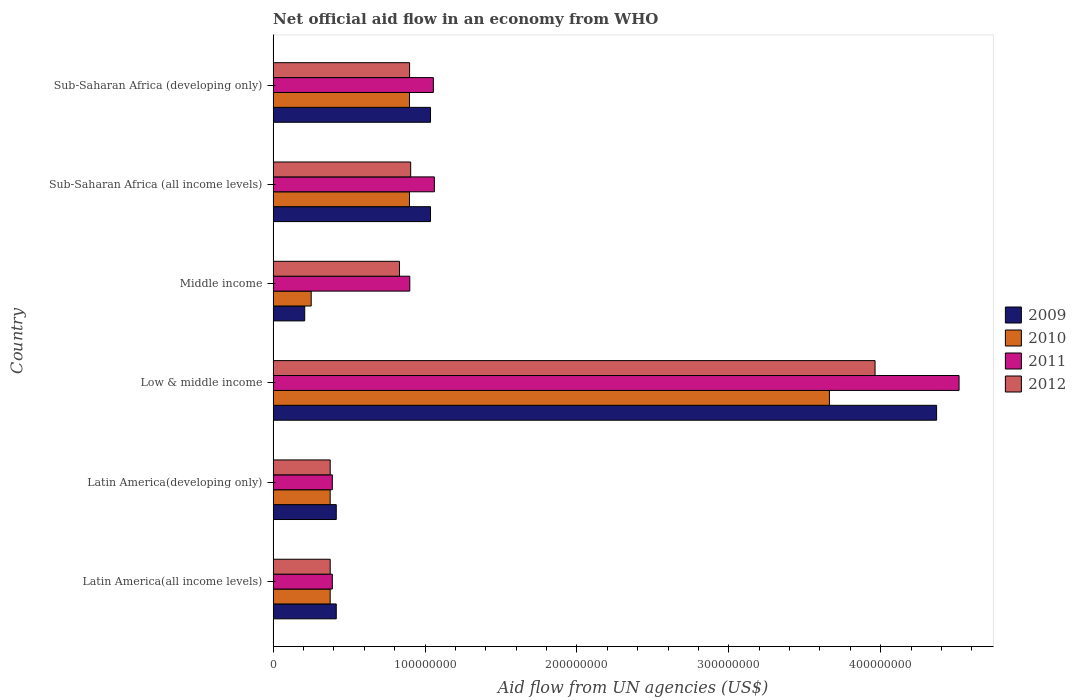How many groups of bars are there?
Offer a terse response. 6. Are the number of bars per tick equal to the number of legend labels?
Ensure brevity in your answer.  Yes. How many bars are there on the 1st tick from the top?
Your response must be concise. 4. How many bars are there on the 4th tick from the bottom?
Give a very brief answer. 4. What is the label of the 5th group of bars from the top?
Offer a very short reply. Latin America(developing only). In how many cases, is the number of bars for a given country not equal to the number of legend labels?
Make the answer very short. 0. What is the net official aid flow in 2009 in Sub-Saharan Africa (developing only)?
Provide a succinct answer. 1.04e+08. Across all countries, what is the maximum net official aid flow in 2010?
Provide a succinct answer. 3.66e+08. Across all countries, what is the minimum net official aid flow in 2010?
Ensure brevity in your answer.  2.51e+07. In which country was the net official aid flow in 2010 minimum?
Ensure brevity in your answer.  Middle income. What is the total net official aid flow in 2011 in the graph?
Offer a very short reply. 8.31e+08. What is the difference between the net official aid flow in 2009 in Low & middle income and that in Middle income?
Ensure brevity in your answer.  4.16e+08. What is the difference between the net official aid flow in 2010 in Sub-Saharan Africa (all income levels) and the net official aid flow in 2011 in Low & middle income?
Give a very brief answer. -3.62e+08. What is the average net official aid flow in 2012 per country?
Your response must be concise. 1.23e+08. What is the difference between the net official aid flow in 2011 and net official aid flow in 2012 in Low & middle income?
Provide a succinct answer. 5.53e+07. What is the ratio of the net official aid flow in 2010 in Latin America(developing only) to that in Low & middle income?
Ensure brevity in your answer.  0.1. Is the net official aid flow in 2010 in Middle income less than that in Sub-Saharan Africa (all income levels)?
Ensure brevity in your answer.  Yes. Is the difference between the net official aid flow in 2011 in Latin America(all income levels) and Latin America(developing only) greater than the difference between the net official aid flow in 2012 in Latin America(all income levels) and Latin America(developing only)?
Your answer should be very brief. No. What is the difference between the highest and the second highest net official aid flow in 2011?
Your response must be concise. 3.45e+08. What is the difference between the highest and the lowest net official aid flow in 2010?
Provide a succinct answer. 3.41e+08. In how many countries, is the net official aid flow in 2009 greater than the average net official aid flow in 2009 taken over all countries?
Your answer should be very brief. 1. Is it the case that in every country, the sum of the net official aid flow in 2012 and net official aid flow in 2009 is greater than the sum of net official aid flow in 2011 and net official aid flow in 2010?
Provide a short and direct response. Yes. Is it the case that in every country, the sum of the net official aid flow in 2009 and net official aid flow in 2012 is greater than the net official aid flow in 2010?
Give a very brief answer. Yes. How many bars are there?
Keep it short and to the point. 24. How many countries are there in the graph?
Ensure brevity in your answer.  6. Does the graph contain grids?
Offer a terse response. No. Where does the legend appear in the graph?
Offer a terse response. Center right. How are the legend labels stacked?
Your answer should be compact. Vertical. What is the title of the graph?
Provide a succinct answer. Net official aid flow in an economy from WHO. What is the label or title of the X-axis?
Your answer should be compact. Aid flow from UN agencies (US$). What is the Aid flow from UN agencies (US$) of 2009 in Latin America(all income levels)?
Give a very brief answer. 4.16e+07. What is the Aid flow from UN agencies (US$) of 2010 in Latin America(all income levels)?
Keep it short and to the point. 3.76e+07. What is the Aid flow from UN agencies (US$) of 2011 in Latin America(all income levels)?
Provide a succinct answer. 3.90e+07. What is the Aid flow from UN agencies (US$) in 2012 in Latin America(all income levels)?
Offer a very short reply. 3.76e+07. What is the Aid flow from UN agencies (US$) of 2009 in Latin America(developing only)?
Ensure brevity in your answer.  4.16e+07. What is the Aid flow from UN agencies (US$) in 2010 in Latin America(developing only)?
Offer a terse response. 3.76e+07. What is the Aid flow from UN agencies (US$) in 2011 in Latin America(developing only)?
Keep it short and to the point. 3.90e+07. What is the Aid flow from UN agencies (US$) in 2012 in Latin America(developing only)?
Provide a short and direct response. 3.76e+07. What is the Aid flow from UN agencies (US$) in 2009 in Low & middle income?
Your response must be concise. 4.37e+08. What is the Aid flow from UN agencies (US$) in 2010 in Low & middle income?
Provide a succinct answer. 3.66e+08. What is the Aid flow from UN agencies (US$) of 2011 in Low & middle income?
Your answer should be very brief. 4.52e+08. What is the Aid flow from UN agencies (US$) in 2012 in Low & middle income?
Keep it short and to the point. 3.96e+08. What is the Aid flow from UN agencies (US$) of 2009 in Middle income?
Offer a very short reply. 2.08e+07. What is the Aid flow from UN agencies (US$) of 2010 in Middle income?
Your response must be concise. 2.51e+07. What is the Aid flow from UN agencies (US$) of 2011 in Middle income?
Give a very brief answer. 9.00e+07. What is the Aid flow from UN agencies (US$) in 2012 in Middle income?
Provide a succinct answer. 8.32e+07. What is the Aid flow from UN agencies (US$) of 2009 in Sub-Saharan Africa (all income levels)?
Offer a terse response. 1.04e+08. What is the Aid flow from UN agencies (US$) of 2010 in Sub-Saharan Africa (all income levels)?
Make the answer very short. 8.98e+07. What is the Aid flow from UN agencies (US$) of 2011 in Sub-Saharan Africa (all income levels)?
Provide a succinct answer. 1.06e+08. What is the Aid flow from UN agencies (US$) of 2012 in Sub-Saharan Africa (all income levels)?
Keep it short and to the point. 9.06e+07. What is the Aid flow from UN agencies (US$) of 2009 in Sub-Saharan Africa (developing only)?
Ensure brevity in your answer.  1.04e+08. What is the Aid flow from UN agencies (US$) in 2010 in Sub-Saharan Africa (developing only)?
Your response must be concise. 8.98e+07. What is the Aid flow from UN agencies (US$) of 2011 in Sub-Saharan Africa (developing only)?
Offer a terse response. 1.05e+08. What is the Aid flow from UN agencies (US$) of 2012 in Sub-Saharan Africa (developing only)?
Offer a terse response. 8.98e+07. Across all countries, what is the maximum Aid flow from UN agencies (US$) of 2009?
Your answer should be very brief. 4.37e+08. Across all countries, what is the maximum Aid flow from UN agencies (US$) of 2010?
Make the answer very short. 3.66e+08. Across all countries, what is the maximum Aid flow from UN agencies (US$) in 2011?
Your answer should be very brief. 4.52e+08. Across all countries, what is the maximum Aid flow from UN agencies (US$) of 2012?
Offer a terse response. 3.96e+08. Across all countries, what is the minimum Aid flow from UN agencies (US$) of 2009?
Your answer should be very brief. 2.08e+07. Across all countries, what is the minimum Aid flow from UN agencies (US$) of 2010?
Provide a short and direct response. 2.51e+07. Across all countries, what is the minimum Aid flow from UN agencies (US$) of 2011?
Provide a succinct answer. 3.90e+07. Across all countries, what is the minimum Aid flow from UN agencies (US$) of 2012?
Your answer should be very brief. 3.76e+07. What is the total Aid flow from UN agencies (US$) of 2009 in the graph?
Your response must be concise. 7.48e+08. What is the total Aid flow from UN agencies (US$) in 2010 in the graph?
Give a very brief answer. 6.46e+08. What is the total Aid flow from UN agencies (US$) of 2011 in the graph?
Ensure brevity in your answer.  8.31e+08. What is the total Aid flow from UN agencies (US$) of 2012 in the graph?
Your response must be concise. 7.35e+08. What is the difference between the Aid flow from UN agencies (US$) in 2009 in Latin America(all income levels) and that in Latin America(developing only)?
Provide a short and direct response. 0. What is the difference between the Aid flow from UN agencies (US$) in 2010 in Latin America(all income levels) and that in Latin America(developing only)?
Your response must be concise. 0. What is the difference between the Aid flow from UN agencies (US$) of 2012 in Latin America(all income levels) and that in Latin America(developing only)?
Make the answer very short. 0. What is the difference between the Aid flow from UN agencies (US$) in 2009 in Latin America(all income levels) and that in Low & middle income?
Your answer should be very brief. -3.95e+08. What is the difference between the Aid flow from UN agencies (US$) in 2010 in Latin America(all income levels) and that in Low & middle income?
Your response must be concise. -3.29e+08. What is the difference between the Aid flow from UN agencies (US$) of 2011 in Latin America(all income levels) and that in Low & middle income?
Ensure brevity in your answer.  -4.13e+08. What is the difference between the Aid flow from UN agencies (US$) in 2012 in Latin America(all income levels) and that in Low & middle income?
Make the answer very short. -3.59e+08. What is the difference between the Aid flow from UN agencies (US$) of 2009 in Latin America(all income levels) and that in Middle income?
Offer a terse response. 2.08e+07. What is the difference between the Aid flow from UN agencies (US$) of 2010 in Latin America(all income levels) and that in Middle income?
Offer a terse response. 1.25e+07. What is the difference between the Aid flow from UN agencies (US$) of 2011 in Latin America(all income levels) and that in Middle income?
Provide a short and direct response. -5.10e+07. What is the difference between the Aid flow from UN agencies (US$) of 2012 in Latin America(all income levels) and that in Middle income?
Ensure brevity in your answer.  -4.56e+07. What is the difference between the Aid flow from UN agencies (US$) of 2009 in Latin America(all income levels) and that in Sub-Saharan Africa (all income levels)?
Keep it short and to the point. -6.20e+07. What is the difference between the Aid flow from UN agencies (US$) of 2010 in Latin America(all income levels) and that in Sub-Saharan Africa (all income levels)?
Ensure brevity in your answer.  -5.22e+07. What is the difference between the Aid flow from UN agencies (US$) in 2011 in Latin America(all income levels) and that in Sub-Saharan Africa (all income levels)?
Keep it short and to the point. -6.72e+07. What is the difference between the Aid flow from UN agencies (US$) of 2012 in Latin America(all income levels) and that in Sub-Saharan Africa (all income levels)?
Make the answer very short. -5.30e+07. What is the difference between the Aid flow from UN agencies (US$) of 2009 in Latin America(all income levels) and that in Sub-Saharan Africa (developing only)?
Offer a terse response. -6.20e+07. What is the difference between the Aid flow from UN agencies (US$) in 2010 in Latin America(all income levels) and that in Sub-Saharan Africa (developing only)?
Your answer should be compact. -5.22e+07. What is the difference between the Aid flow from UN agencies (US$) of 2011 in Latin America(all income levels) and that in Sub-Saharan Africa (developing only)?
Make the answer very short. -6.65e+07. What is the difference between the Aid flow from UN agencies (US$) in 2012 in Latin America(all income levels) and that in Sub-Saharan Africa (developing only)?
Offer a terse response. -5.23e+07. What is the difference between the Aid flow from UN agencies (US$) of 2009 in Latin America(developing only) and that in Low & middle income?
Provide a succinct answer. -3.95e+08. What is the difference between the Aid flow from UN agencies (US$) in 2010 in Latin America(developing only) and that in Low & middle income?
Your response must be concise. -3.29e+08. What is the difference between the Aid flow from UN agencies (US$) in 2011 in Latin America(developing only) and that in Low & middle income?
Provide a succinct answer. -4.13e+08. What is the difference between the Aid flow from UN agencies (US$) of 2012 in Latin America(developing only) and that in Low & middle income?
Make the answer very short. -3.59e+08. What is the difference between the Aid flow from UN agencies (US$) in 2009 in Latin America(developing only) and that in Middle income?
Your answer should be compact. 2.08e+07. What is the difference between the Aid flow from UN agencies (US$) of 2010 in Latin America(developing only) and that in Middle income?
Provide a short and direct response. 1.25e+07. What is the difference between the Aid flow from UN agencies (US$) in 2011 in Latin America(developing only) and that in Middle income?
Make the answer very short. -5.10e+07. What is the difference between the Aid flow from UN agencies (US$) in 2012 in Latin America(developing only) and that in Middle income?
Provide a succinct answer. -4.56e+07. What is the difference between the Aid flow from UN agencies (US$) of 2009 in Latin America(developing only) and that in Sub-Saharan Africa (all income levels)?
Offer a very short reply. -6.20e+07. What is the difference between the Aid flow from UN agencies (US$) of 2010 in Latin America(developing only) and that in Sub-Saharan Africa (all income levels)?
Your answer should be very brief. -5.22e+07. What is the difference between the Aid flow from UN agencies (US$) of 2011 in Latin America(developing only) and that in Sub-Saharan Africa (all income levels)?
Your response must be concise. -6.72e+07. What is the difference between the Aid flow from UN agencies (US$) of 2012 in Latin America(developing only) and that in Sub-Saharan Africa (all income levels)?
Keep it short and to the point. -5.30e+07. What is the difference between the Aid flow from UN agencies (US$) of 2009 in Latin America(developing only) and that in Sub-Saharan Africa (developing only)?
Your response must be concise. -6.20e+07. What is the difference between the Aid flow from UN agencies (US$) in 2010 in Latin America(developing only) and that in Sub-Saharan Africa (developing only)?
Your answer should be very brief. -5.22e+07. What is the difference between the Aid flow from UN agencies (US$) of 2011 in Latin America(developing only) and that in Sub-Saharan Africa (developing only)?
Your response must be concise. -6.65e+07. What is the difference between the Aid flow from UN agencies (US$) of 2012 in Latin America(developing only) and that in Sub-Saharan Africa (developing only)?
Provide a short and direct response. -5.23e+07. What is the difference between the Aid flow from UN agencies (US$) of 2009 in Low & middle income and that in Middle income?
Your response must be concise. 4.16e+08. What is the difference between the Aid flow from UN agencies (US$) of 2010 in Low & middle income and that in Middle income?
Your response must be concise. 3.41e+08. What is the difference between the Aid flow from UN agencies (US$) in 2011 in Low & middle income and that in Middle income?
Offer a very short reply. 3.62e+08. What is the difference between the Aid flow from UN agencies (US$) of 2012 in Low & middle income and that in Middle income?
Keep it short and to the point. 3.13e+08. What is the difference between the Aid flow from UN agencies (US$) of 2009 in Low & middle income and that in Sub-Saharan Africa (all income levels)?
Ensure brevity in your answer.  3.33e+08. What is the difference between the Aid flow from UN agencies (US$) of 2010 in Low & middle income and that in Sub-Saharan Africa (all income levels)?
Your answer should be compact. 2.76e+08. What is the difference between the Aid flow from UN agencies (US$) of 2011 in Low & middle income and that in Sub-Saharan Africa (all income levels)?
Your response must be concise. 3.45e+08. What is the difference between the Aid flow from UN agencies (US$) in 2012 in Low & middle income and that in Sub-Saharan Africa (all income levels)?
Your answer should be compact. 3.06e+08. What is the difference between the Aid flow from UN agencies (US$) of 2009 in Low & middle income and that in Sub-Saharan Africa (developing only)?
Offer a terse response. 3.33e+08. What is the difference between the Aid flow from UN agencies (US$) of 2010 in Low & middle income and that in Sub-Saharan Africa (developing only)?
Your answer should be compact. 2.76e+08. What is the difference between the Aid flow from UN agencies (US$) of 2011 in Low & middle income and that in Sub-Saharan Africa (developing only)?
Keep it short and to the point. 3.46e+08. What is the difference between the Aid flow from UN agencies (US$) of 2012 in Low & middle income and that in Sub-Saharan Africa (developing only)?
Make the answer very short. 3.06e+08. What is the difference between the Aid flow from UN agencies (US$) in 2009 in Middle income and that in Sub-Saharan Africa (all income levels)?
Give a very brief answer. -8.28e+07. What is the difference between the Aid flow from UN agencies (US$) in 2010 in Middle income and that in Sub-Saharan Africa (all income levels)?
Provide a short and direct response. -6.47e+07. What is the difference between the Aid flow from UN agencies (US$) of 2011 in Middle income and that in Sub-Saharan Africa (all income levels)?
Your response must be concise. -1.62e+07. What is the difference between the Aid flow from UN agencies (US$) in 2012 in Middle income and that in Sub-Saharan Africa (all income levels)?
Provide a succinct answer. -7.39e+06. What is the difference between the Aid flow from UN agencies (US$) of 2009 in Middle income and that in Sub-Saharan Africa (developing only)?
Your answer should be compact. -8.28e+07. What is the difference between the Aid flow from UN agencies (US$) of 2010 in Middle income and that in Sub-Saharan Africa (developing only)?
Your answer should be very brief. -6.47e+07. What is the difference between the Aid flow from UN agencies (US$) of 2011 in Middle income and that in Sub-Saharan Africa (developing only)?
Your response must be concise. -1.55e+07. What is the difference between the Aid flow from UN agencies (US$) in 2012 in Middle income and that in Sub-Saharan Africa (developing only)?
Make the answer very short. -6.67e+06. What is the difference between the Aid flow from UN agencies (US$) in 2009 in Sub-Saharan Africa (all income levels) and that in Sub-Saharan Africa (developing only)?
Provide a short and direct response. 0. What is the difference between the Aid flow from UN agencies (US$) of 2011 in Sub-Saharan Africa (all income levels) and that in Sub-Saharan Africa (developing only)?
Make the answer very short. 6.70e+05. What is the difference between the Aid flow from UN agencies (US$) in 2012 in Sub-Saharan Africa (all income levels) and that in Sub-Saharan Africa (developing only)?
Keep it short and to the point. 7.20e+05. What is the difference between the Aid flow from UN agencies (US$) in 2009 in Latin America(all income levels) and the Aid flow from UN agencies (US$) in 2010 in Latin America(developing only)?
Make the answer very short. 4.01e+06. What is the difference between the Aid flow from UN agencies (US$) in 2009 in Latin America(all income levels) and the Aid flow from UN agencies (US$) in 2011 in Latin America(developing only)?
Offer a very short reply. 2.59e+06. What is the difference between the Aid flow from UN agencies (US$) of 2009 in Latin America(all income levels) and the Aid flow from UN agencies (US$) of 2012 in Latin America(developing only)?
Make the answer very short. 3.99e+06. What is the difference between the Aid flow from UN agencies (US$) of 2010 in Latin America(all income levels) and the Aid flow from UN agencies (US$) of 2011 in Latin America(developing only)?
Give a very brief answer. -1.42e+06. What is the difference between the Aid flow from UN agencies (US$) of 2011 in Latin America(all income levels) and the Aid flow from UN agencies (US$) of 2012 in Latin America(developing only)?
Ensure brevity in your answer.  1.40e+06. What is the difference between the Aid flow from UN agencies (US$) of 2009 in Latin America(all income levels) and the Aid flow from UN agencies (US$) of 2010 in Low & middle income?
Offer a terse response. -3.25e+08. What is the difference between the Aid flow from UN agencies (US$) in 2009 in Latin America(all income levels) and the Aid flow from UN agencies (US$) in 2011 in Low & middle income?
Ensure brevity in your answer.  -4.10e+08. What is the difference between the Aid flow from UN agencies (US$) of 2009 in Latin America(all income levels) and the Aid flow from UN agencies (US$) of 2012 in Low & middle income?
Ensure brevity in your answer.  -3.55e+08. What is the difference between the Aid flow from UN agencies (US$) of 2010 in Latin America(all income levels) and the Aid flow from UN agencies (US$) of 2011 in Low & middle income?
Your answer should be compact. -4.14e+08. What is the difference between the Aid flow from UN agencies (US$) in 2010 in Latin America(all income levels) and the Aid flow from UN agencies (US$) in 2012 in Low & middle income?
Give a very brief answer. -3.59e+08. What is the difference between the Aid flow from UN agencies (US$) in 2011 in Latin America(all income levels) and the Aid flow from UN agencies (US$) in 2012 in Low & middle income?
Your answer should be compact. -3.57e+08. What is the difference between the Aid flow from UN agencies (US$) of 2009 in Latin America(all income levels) and the Aid flow from UN agencies (US$) of 2010 in Middle income?
Your answer should be very brief. 1.65e+07. What is the difference between the Aid flow from UN agencies (US$) of 2009 in Latin America(all income levels) and the Aid flow from UN agencies (US$) of 2011 in Middle income?
Give a very brief answer. -4.84e+07. What is the difference between the Aid flow from UN agencies (US$) of 2009 in Latin America(all income levels) and the Aid flow from UN agencies (US$) of 2012 in Middle income?
Give a very brief answer. -4.16e+07. What is the difference between the Aid flow from UN agencies (US$) in 2010 in Latin America(all income levels) and the Aid flow from UN agencies (US$) in 2011 in Middle income?
Keep it short and to the point. -5.24e+07. What is the difference between the Aid flow from UN agencies (US$) in 2010 in Latin America(all income levels) and the Aid flow from UN agencies (US$) in 2012 in Middle income?
Your answer should be compact. -4.56e+07. What is the difference between the Aid flow from UN agencies (US$) of 2011 in Latin America(all income levels) and the Aid flow from UN agencies (US$) of 2012 in Middle income?
Provide a succinct answer. -4.42e+07. What is the difference between the Aid flow from UN agencies (US$) of 2009 in Latin America(all income levels) and the Aid flow from UN agencies (US$) of 2010 in Sub-Saharan Africa (all income levels)?
Ensure brevity in your answer.  -4.82e+07. What is the difference between the Aid flow from UN agencies (US$) of 2009 in Latin America(all income levels) and the Aid flow from UN agencies (US$) of 2011 in Sub-Saharan Africa (all income levels)?
Provide a short and direct response. -6.46e+07. What is the difference between the Aid flow from UN agencies (US$) in 2009 in Latin America(all income levels) and the Aid flow from UN agencies (US$) in 2012 in Sub-Saharan Africa (all income levels)?
Your response must be concise. -4.90e+07. What is the difference between the Aid flow from UN agencies (US$) of 2010 in Latin America(all income levels) and the Aid flow from UN agencies (US$) of 2011 in Sub-Saharan Africa (all income levels)?
Give a very brief answer. -6.86e+07. What is the difference between the Aid flow from UN agencies (US$) in 2010 in Latin America(all income levels) and the Aid flow from UN agencies (US$) in 2012 in Sub-Saharan Africa (all income levels)?
Provide a succinct answer. -5.30e+07. What is the difference between the Aid flow from UN agencies (US$) of 2011 in Latin America(all income levels) and the Aid flow from UN agencies (US$) of 2012 in Sub-Saharan Africa (all income levels)?
Your response must be concise. -5.16e+07. What is the difference between the Aid flow from UN agencies (US$) in 2009 in Latin America(all income levels) and the Aid flow from UN agencies (US$) in 2010 in Sub-Saharan Africa (developing only)?
Give a very brief answer. -4.82e+07. What is the difference between the Aid flow from UN agencies (US$) in 2009 in Latin America(all income levels) and the Aid flow from UN agencies (US$) in 2011 in Sub-Saharan Africa (developing only)?
Ensure brevity in your answer.  -6.39e+07. What is the difference between the Aid flow from UN agencies (US$) in 2009 in Latin America(all income levels) and the Aid flow from UN agencies (US$) in 2012 in Sub-Saharan Africa (developing only)?
Ensure brevity in your answer.  -4.83e+07. What is the difference between the Aid flow from UN agencies (US$) in 2010 in Latin America(all income levels) and the Aid flow from UN agencies (US$) in 2011 in Sub-Saharan Africa (developing only)?
Your answer should be compact. -6.79e+07. What is the difference between the Aid flow from UN agencies (US$) of 2010 in Latin America(all income levels) and the Aid flow from UN agencies (US$) of 2012 in Sub-Saharan Africa (developing only)?
Provide a succinct answer. -5.23e+07. What is the difference between the Aid flow from UN agencies (US$) in 2011 in Latin America(all income levels) and the Aid flow from UN agencies (US$) in 2012 in Sub-Saharan Africa (developing only)?
Make the answer very short. -5.09e+07. What is the difference between the Aid flow from UN agencies (US$) of 2009 in Latin America(developing only) and the Aid flow from UN agencies (US$) of 2010 in Low & middle income?
Ensure brevity in your answer.  -3.25e+08. What is the difference between the Aid flow from UN agencies (US$) of 2009 in Latin America(developing only) and the Aid flow from UN agencies (US$) of 2011 in Low & middle income?
Offer a terse response. -4.10e+08. What is the difference between the Aid flow from UN agencies (US$) of 2009 in Latin America(developing only) and the Aid flow from UN agencies (US$) of 2012 in Low & middle income?
Provide a succinct answer. -3.55e+08. What is the difference between the Aid flow from UN agencies (US$) in 2010 in Latin America(developing only) and the Aid flow from UN agencies (US$) in 2011 in Low & middle income?
Ensure brevity in your answer.  -4.14e+08. What is the difference between the Aid flow from UN agencies (US$) in 2010 in Latin America(developing only) and the Aid flow from UN agencies (US$) in 2012 in Low & middle income?
Offer a terse response. -3.59e+08. What is the difference between the Aid flow from UN agencies (US$) in 2011 in Latin America(developing only) and the Aid flow from UN agencies (US$) in 2012 in Low & middle income?
Ensure brevity in your answer.  -3.57e+08. What is the difference between the Aid flow from UN agencies (US$) of 2009 in Latin America(developing only) and the Aid flow from UN agencies (US$) of 2010 in Middle income?
Your answer should be very brief. 1.65e+07. What is the difference between the Aid flow from UN agencies (US$) in 2009 in Latin America(developing only) and the Aid flow from UN agencies (US$) in 2011 in Middle income?
Keep it short and to the point. -4.84e+07. What is the difference between the Aid flow from UN agencies (US$) in 2009 in Latin America(developing only) and the Aid flow from UN agencies (US$) in 2012 in Middle income?
Ensure brevity in your answer.  -4.16e+07. What is the difference between the Aid flow from UN agencies (US$) of 2010 in Latin America(developing only) and the Aid flow from UN agencies (US$) of 2011 in Middle income?
Your response must be concise. -5.24e+07. What is the difference between the Aid flow from UN agencies (US$) in 2010 in Latin America(developing only) and the Aid flow from UN agencies (US$) in 2012 in Middle income?
Your answer should be very brief. -4.56e+07. What is the difference between the Aid flow from UN agencies (US$) of 2011 in Latin America(developing only) and the Aid flow from UN agencies (US$) of 2012 in Middle income?
Offer a very short reply. -4.42e+07. What is the difference between the Aid flow from UN agencies (US$) of 2009 in Latin America(developing only) and the Aid flow from UN agencies (US$) of 2010 in Sub-Saharan Africa (all income levels)?
Make the answer very short. -4.82e+07. What is the difference between the Aid flow from UN agencies (US$) in 2009 in Latin America(developing only) and the Aid flow from UN agencies (US$) in 2011 in Sub-Saharan Africa (all income levels)?
Your answer should be very brief. -6.46e+07. What is the difference between the Aid flow from UN agencies (US$) of 2009 in Latin America(developing only) and the Aid flow from UN agencies (US$) of 2012 in Sub-Saharan Africa (all income levels)?
Give a very brief answer. -4.90e+07. What is the difference between the Aid flow from UN agencies (US$) in 2010 in Latin America(developing only) and the Aid flow from UN agencies (US$) in 2011 in Sub-Saharan Africa (all income levels)?
Offer a very short reply. -6.86e+07. What is the difference between the Aid flow from UN agencies (US$) in 2010 in Latin America(developing only) and the Aid flow from UN agencies (US$) in 2012 in Sub-Saharan Africa (all income levels)?
Provide a succinct answer. -5.30e+07. What is the difference between the Aid flow from UN agencies (US$) in 2011 in Latin America(developing only) and the Aid flow from UN agencies (US$) in 2012 in Sub-Saharan Africa (all income levels)?
Make the answer very short. -5.16e+07. What is the difference between the Aid flow from UN agencies (US$) of 2009 in Latin America(developing only) and the Aid flow from UN agencies (US$) of 2010 in Sub-Saharan Africa (developing only)?
Your response must be concise. -4.82e+07. What is the difference between the Aid flow from UN agencies (US$) of 2009 in Latin America(developing only) and the Aid flow from UN agencies (US$) of 2011 in Sub-Saharan Africa (developing only)?
Your answer should be compact. -6.39e+07. What is the difference between the Aid flow from UN agencies (US$) in 2009 in Latin America(developing only) and the Aid flow from UN agencies (US$) in 2012 in Sub-Saharan Africa (developing only)?
Ensure brevity in your answer.  -4.83e+07. What is the difference between the Aid flow from UN agencies (US$) of 2010 in Latin America(developing only) and the Aid flow from UN agencies (US$) of 2011 in Sub-Saharan Africa (developing only)?
Offer a terse response. -6.79e+07. What is the difference between the Aid flow from UN agencies (US$) of 2010 in Latin America(developing only) and the Aid flow from UN agencies (US$) of 2012 in Sub-Saharan Africa (developing only)?
Your response must be concise. -5.23e+07. What is the difference between the Aid flow from UN agencies (US$) in 2011 in Latin America(developing only) and the Aid flow from UN agencies (US$) in 2012 in Sub-Saharan Africa (developing only)?
Offer a very short reply. -5.09e+07. What is the difference between the Aid flow from UN agencies (US$) in 2009 in Low & middle income and the Aid flow from UN agencies (US$) in 2010 in Middle income?
Keep it short and to the point. 4.12e+08. What is the difference between the Aid flow from UN agencies (US$) of 2009 in Low & middle income and the Aid flow from UN agencies (US$) of 2011 in Middle income?
Your answer should be compact. 3.47e+08. What is the difference between the Aid flow from UN agencies (US$) in 2009 in Low & middle income and the Aid flow from UN agencies (US$) in 2012 in Middle income?
Offer a very short reply. 3.54e+08. What is the difference between the Aid flow from UN agencies (US$) in 2010 in Low & middle income and the Aid flow from UN agencies (US$) in 2011 in Middle income?
Your response must be concise. 2.76e+08. What is the difference between the Aid flow from UN agencies (US$) of 2010 in Low & middle income and the Aid flow from UN agencies (US$) of 2012 in Middle income?
Make the answer very short. 2.83e+08. What is the difference between the Aid flow from UN agencies (US$) of 2011 in Low & middle income and the Aid flow from UN agencies (US$) of 2012 in Middle income?
Make the answer very short. 3.68e+08. What is the difference between the Aid flow from UN agencies (US$) of 2009 in Low & middle income and the Aid flow from UN agencies (US$) of 2010 in Sub-Saharan Africa (all income levels)?
Make the answer very short. 3.47e+08. What is the difference between the Aid flow from UN agencies (US$) in 2009 in Low & middle income and the Aid flow from UN agencies (US$) in 2011 in Sub-Saharan Africa (all income levels)?
Ensure brevity in your answer.  3.31e+08. What is the difference between the Aid flow from UN agencies (US$) of 2009 in Low & middle income and the Aid flow from UN agencies (US$) of 2012 in Sub-Saharan Africa (all income levels)?
Make the answer very short. 3.46e+08. What is the difference between the Aid flow from UN agencies (US$) of 2010 in Low & middle income and the Aid flow from UN agencies (US$) of 2011 in Sub-Saharan Africa (all income levels)?
Offer a terse response. 2.60e+08. What is the difference between the Aid flow from UN agencies (US$) of 2010 in Low & middle income and the Aid flow from UN agencies (US$) of 2012 in Sub-Saharan Africa (all income levels)?
Keep it short and to the point. 2.76e+08. What is the difference between the Aid flow from UN agencies (US$) in 2011 in Low & middle income and the Aid flow from UN agencies (US$) in 2012 in Sub-Saharan Africa (all income levels)?
Ensure brevity in your answer.  3.61e+08. What is the difference between the Aid flow from UN agencies (US$) of 2009 in Low & middle income and the Aid flow from UN agencies (US$) of 2010 in Sub-Saharan Africa (developing only)?
Offer a very short reply. 3.47e+08. What is the difference between the Aid flow from UN agencies (US$) of 2009 in Low & middle income and the Aid flow from UN agencies (US$) of 2011 in Sub-Saharan Africa (developing only)?
Give a very brief answer. 3.31e+08. What is the difference between the Aid flow from UN agencies (US$) in 2009 in Low & middle income and the Aid flow from UN agencies (US$) in 2012 in Sub-Saharan Africa (developing only)?
Give a very brief answer. 3.47e+08. What is the difference between the Aid flow from UN agencies (US$) in 2010 in Low & middle income and the Aid flow from UN agencies (US$) in 2011 in Sub-Saharan Africa (developing only)?
Offer a terse response. 2.61e+08. What is the difference between the Aid flow from UN agencies (US$) in 2010 in Low & middle income and the Aid flow from UN agencies (US$) in 2012 in Sub-Saharan Africa (developing only)?
Your answer should be compact. 2.76e+08. What is the difference between the Aid flow from UN agencies (US$) in 2011 in Low & middle income and the Aid flow from UN agencies (US$) in 2012 in Sub-Saharan Africa (developing only)?
Provide a succinct answer. 3.62e+08. What is the difference between the Aid flow from UN agencies (US$) of 2009 in Middle income and the Aid flow from UN agencies (US$) of 2010 in Sub-Saharan Africa (all income levels)?
Offer a very short reply. -6.90e+07. What is the difference between the Aid flow from UN agencies (US$) of 2009 in Middle income and the Aid flow from UN agencies (US$) of 2011 in Sub-Saharan Africa (all income levels)?
Provide a short and direct response. -8.54e+07. What is the difference between the Aid flow from UN agencies (US$) of 2009 in Middle income and the Aid flow from UN agencies (US$) of 2012 in Sub-Saharan Africa (all income levels)?
Provide a succinct answer. -6.98e+07. What is the difference between the Aid flow from UN agencies (US$) of 2010 in Middle income and the Aid flow from UN agencies (US$) of 2011 in Sub-Saharan Africa (all income levels)?
Your response must be concise. -8.11e+07. What is the difference between the Aid flow from UN agencies (US$) of 2010 in Middle income and the Aid flow from UN agencies (US$) of 2012 in Sub-Saharan Africa (all income levels)?
Give a very brief answer. -6.55e+07. What is the difference between the Aid flow from UN agencies (US$) of 2011 in Middle income and the Aid flow from UN agencies (US$) of 2012 in Sub-Saharan Africa (all income levels)?
Offer a terse response. -5.90e+05. What is the difference between the Aid flow from UN agencies (US$) in 2009 in Middle income and the Aid flow from UN agencies (US$) in 2010 in Sub-Saharan Africa (developing only)?
Your response must be concise. -6.90e+07. What is the difference between the Aid flow from UN agencies (US$) in 2009 in Middle income and the Aid flow from UN agencies (US$) in 2011 in Sub-Saharan Africa (developing only)?
Offer a terse response. -8.47e+07. What is the difference between the Aid flow from UN agencies (US$) of 2009 in Middle income and the Aid flow from UN agencies (US$) of 2012 in Sub-Saharan Africa (developing only)?
Make the answer very short. -6.90e+07. What is the difference between the Aid flow from UN agencies (US$) in 2010 in Middle income and the Aid flow from UN agencies (US$) in 2011 in Sub-Saharan Africa (developing only)?
Ensure brevity in your answer.  -8.04e+07. What is the difference between the Aid flow from UN agencies (US$) in 2010 in Middle income and the Aid flow from UN agencies (US$) in 2012 in Sub-Saharan Africa (developing only)?
Provide a succinct answer. -6.48e+07. What is the difference between the Aid flow from UN agencies (US$) of 2009 in Sub-Saharan Africa (all income levels) and the Aid flow from UN agencies (US$) of 2010 in Sub-Saharan Africa (developing only)?
Offer a terse response. 1.39e+07. What is the difference between the Aid flow from UN agencies (US$) of 2009 in Sub-Saharan Africa (all income levels) and the Aid flow from UN agencies (US$) of 2011 in Sub-Saharan Africa (developing only)?
Ensure brevity in your answer.  -1.86e+06. What is the difference between the Aid flow from UN agencies (US$) in 2009 in Sub-Saharan Africa (all income levels) and the Aid flow from UN agencies (US$) in 2012 in Sub-Saharan Africa (developing only)?
Your answer should be very brief. 1.38e+07. What is the difference between the Aid flow from UN agencies (US$) in 2010 in Sub-Saharan Africa (all income levels) and the Aid flow from UN agencies (US$) in 2011 in Sub-Saharan Africa (developing only)?
Your answer should be compact. -1.57e+07. What is the difference between the Aid flow from UN agencies (US$) in 2011 in Sub-Saharan Africa (all income levels) and the Aid flow from UN agencies (US$) in 2012 in Sub-Saharan Africa (developing only)?
Your answer should be very brief. 1.63e+07. What is the average Aid flow from UN agencies (US$) in 2009 per country?
Give a very brief answer. 1.25e+08. What is the average Aid flow from UN agencies (US$) in 2010 per country?
Keep it short and to the point. 1.08e+08. What is the average Aid flow from UN agencies (US$) in 2011 per country?
Ensure brevity in your answer.  1.39e+08. What is the average Aid flow from UN agencies (US$) of 2012 per country?
Offer a very short reply. 1.23e+08. What is the difference between the Aid flow from UN agencies (US$) in 2009 and Aid flow from UN agencies (US$) in 2010 in Latin America(all income levels)?
Make the answer very short. 4.01e+06. What is the difference between the Aid flow from UN agencies (US$) of 2009 and Aid flow from UN agencies (US$) of 2011 in Latin America(all income levels)?
Offer a very short reply. 2.59e+06. What is the difference between the Aid flow from UN agencies (US$) in 2009 and Aid flow from UN agencies (US$) in 2012 in Latin America(all income levels)?
Make the answer very short. 3.99e+06. What is the difference between the Aid flow from UN agencies (US$) of 2010 and Aid flow from UN agencies (US$) of 2011 in Latin America(all income levels)?
Provide a short and direct response. -1.42e+06. What is the difference between the Aid flow from UN agencies (US$) of 2010 and Aid flow from UN agencies (US$) of 2012 in Latin America(all income levels)?
Your response must be concise. -2.00e+04. What is the difference between the Aid flow from UN agencies (US$) in 2011 and Aid flow from UN agencies (US$) in 2012 in Latin America(all income levels)?
Keep it short and to the point. 1.40e+06. What is the difference between the Aid flow from UN agencies (US$) of 2009 and Aid flow from UN agencies (US$) of 2010 in Latin America(developing only)?
Offer a very short reply. 4.01e+06. What is the difference between the Aid flow from UN agencies (US$) in 2009 and Aid flow from UN agencies (US$) in 2011 in Latin America(developing only)?
Offer a terse response. 2.59e+06. What is the difference between the Aid flow from UN agencies (US$) of 2009 and Aid flow from UN agencies (US$) of 2012 in Latin America(developing only)?
Provide a short and direct response. 3.99e+06. What is the difference between the Aid flow from UN agencies (US$) of 2010 and Aid flow from UN agencies (US$) of 2011 in Latin America(developing only)?
Your answer should be very brief. -1.42e+06. What is the difference between the Aid flow from UN agencies (US$) in 2010 and Aid flow from UN agencies (US$) in 2012 in Latin America(developing only)?
Make the answer very short. -2.00e+04. What is the difference between the Aid flow from UN agencies (US$) in 2011 and Aid flow from UN agencies (US$) in 2012 in Latin America(developing only)?
Offer a terse response. 1.40e+06. What is the difference between the Aid flow from UN agencies (US$) of 2009 and Aid flow from UN agencies (US$) of 2010 in Low & middle income?
Offer a very short reply. 7.06e+07. What is the difference between the Aid flow from UN agencies (US$) of 2009 and Aid flow from UN agencies (US$) of 2011 in Low & middle income?
Provide a succinct answer. -1.48e+07. What is the difference between the Aid flow from UN agencies (US$) in 2009 and Aid flow from UN agencies (US$) in 2012 in Low & middle income?
Ensure brevity in your answer.  4.05e+07. What is the difference between the Aid flow from UN agencies (US$) of 2010 and Aid flow from UN agencies (US$) of 2011 in Low & middle income?
Offer a very short reply. -8.54e+07. What is the difference between the Aid flow from UN agencies (US$) in 2010 and Aid flow from UN agencies (US$) in 2012 in Low & middle income?
Provide a short and direct response. -3.00e+07. What is the difference between the Aid flow from UN agencies (US$) in 2011 and Aid flow from UN agencies (US$) in 2012 in Low & middle income?
Provide a short and direct response. 5.53e+07. What is the difference between the Aid flow from UN agencies (US$) in 2009 and Aid flow from UN agencies (US$) in 2010 in Middle income?
Give a very brief answer. -4.27e+06. What is the difference between the Aid flow from UN agencies (US$) in 2009 and Aid flow from UN agencies (US$) in 2011 in Middle income?
Offer a terse response. -6.92e+07. What is the difference between the Aid flow from UN agencies (US$) of 2009 and Aid flow from UN agencies (US$) of 2012 in Middle income?
Offer a very short reply. -6.24e+07. What is the difference between the Aid flow from UN agencies (US$) in 2010 and Aid flow from UN agencies (US$) in 2011 in Middle income?
Your answer should be compact. -6.49e+07. What is the difference between the Aid flow from UN agencies (US$) in 2010 and Aid flow from UN agencies (US$) in 2012 in Middle income?
Keep it short and to the point. -5.81e+07. What is the difference between the Aid flow from UN agencies (US$) in 2011 and Aid flow from UN agencies (US$) in 2012 in Middle income?
Your answer should be very brief. 6.80e+06. What is the difference between the Aid flow from UN agencies (US$) of 2009 and Aid flow from UN agencies (US$) of 2010 in Sub-Saharan Africa (all income levels)?
Make the answer very short. 1.39e+07. What is the difference between the Aid flow from UN agencies (US$) of 2009 and Aid flow from UN agencies (US$) of 2011 in Sub-Saharan Africa (all income levels)?
Your response must be concise. -2.53e+06. What is the difference between the Aid flow from UN agencies (US$) in 2009 and Aid flow from UN agencies (US$) in 2012 in Sub-Saharan Africa (all income levels)?
Offer a terse response. 1.30e+07. What is the difference between the Aid flow from UN agencies (US$) of 2010 and Aid flow from UN agencies (US$) of 2011 in Sub-Saharan Africa (all income levels)?
Give a very brief answer. -1.64e+07. What is the difference between the Aid flow from UN agencies (US$) of 2010 and Aid flow from UN agencies (US$) of 2012 in Sub-Saharan Africa (all income levels)?
Provide a short and direct response. -8.10e+05. What is the difference between the Aid flow from UN agencies (US$) in 2011 and Aid flow from UN agencies (US$) in 2012 in Sub-Saharan Africa (all income levels)?
Offer a very short reply. 1.56e+07. What is the difference between the Aid flow from UN agencies (US$) of 2009 and Aid flow from UN agencies (US$) of 2010 in Sub-Saharan Africa (developing only)?
Make the answer very short. 1.39e+07. What is the difference between the Aid flow from UN agencies (US$) of 2009 and Aid flow from UN agencies (US$) of 2011 in Sub-Saharan Africa (developing only)?
Make the answer very short. -1.86e+06. What is the difference between the Aid flow from UN agencies (US$) in 2009 and Aid flow from UN agencies (US$) in 2012 in Sub-Saharan Africa (developing only)?
Provide a short and direct response. 1.38e+07. What is the difference between the Aid flow from UN agencies (US$) of 2010 and Aid flow from UN agencies (US$) of 2011 in Sub-Saharan Africa (developing only)?
Ensure brevity in your answer.  -1.57e+07. What is the difference between the Aid flow from UN agencies (US$) of 2010 and Aid flow from UN agencies (US$) of 2012 in Sub-Saharan Africa (developing only)?
Make the answer very short. -9.00e+04. What is the difference between the Aid flow from UN agencies (US$) of 2011 and Aid flow from UN agencies (US$) of 2012 in Sub-Saharan Africa (developing only)?
Give a very brief answer. 1.56e+07. What is the ratio of the Aid flow from UN agencies (US$) in 2009 in Latin America(all income levels) to that in Latin America(developing only)?
Provide a succinct answer. 1. What is the ratio of the Aid flow from UN agencies (US$) of 2011 in Latin America(all income levels) to that in Latin America(developing only)?
Provide a short and direct response. 1. What is the ratio of the Aid flow from UN agencies (US$) in 2009 in Latin America(all income levels) to that in Low & middle income?
Ensure brevity in your answer.  0.1. What is the ratio of the Aid flow from UN agencies (US$) in 2010 in Latin America(all income levels) to that in Low & middle income?
Keep it short and to the point. 0.1. What is the ratio of the Aid flow from UN agencies (US$) in 2011 in Latin America(all income levels) to that in Low & middle income?
Ensure brevity in your answer.  0.09. What is the ratio of the Aid flow from UN agencies (US$) in 2012 in Latin America(all income levels) to that in Low & middle income?
Your answer should be very brief. 0.09. What is the ratio of the Aid flow from UN agencies (US$) in 2009 in Latin America(all income levels) to that in Middle income?
Offer a very short reply. 2. What is the ratio of the Aid flow from UN agencies (US$) in 2010 in Latin America(all income levels) to that in Middle income?
Offer a terse response. 1.5. What is the ratio of the Aid flow from UN agencies (US$) of 2011 in Latin America(all income levels) to that in Middle income?
Offer a terse response. 0.43. What is the ratio of the Aid flow from UN agencies (US$) in 2012 in Latin America(all income levels) to that in Middle income?
Provide a short and direct response. 0.45. What is the ratio of the Aid flow from UN agencies (US$) in 2009 in Latin America(all income levels) to that in Sub-Saharan Africa (all income levels)?
Make the answer very short. 0.4. What is the ratio of the Aid flow from UN agencies (US$) of 2010 in Latin America(all income levels) to that in Sub-Saharan Africa (all income levels)?
Your answer should be very brief. 0.42. What is the ratio of the Aid flow from UN agencies (US$) in 2011 in Latin America(all income levels) to that in Sub-Saharan Africa (all income levels)?
Ensure brevity in your answer.  0.37. What is the ratio of the Aid flow from UN agencies (US$) of 2012 in Latin America(all income levels) to that in Sub-Saharan Africa (all income levels)?
Give a very brief answer. 0.41. What is the ratio of the Aid flow from UN agencies (US$) in 2009 in Latin America(all income levels) to that in Sub-Saharan Africa (developing only)?
Ensure brevity in your answer.  0.4. What is the ratio of the Aid flow from UN agencies (US$) in 2010 in Latin America(all income levels) to that in Sub-Saharan Africa (developing only)?
Provide a short and direct response. 0.42. What is the ratio of the Aid flow from UN agencies (US$) in 2011 in Latin America(all income levels) to that in Sub-Saharan Africa (developing only)?
Provide a succinct answer. 0.37. What is the ratio of the Aid flow from UN agencies (US$) in 2012 in Latin America(all income levels) to that in Sub-Saharan Africa (developing only)?
Keep it short and to the point. 0.42. What is the ratio of the Aid flow from UN agencies (US$) in 2009 in Latin America(developing only) to that in Low & middle income?
Provide a short and direct response. 0.1. What is the ratio of the Aid flow from UN agencies (US$) in 2010 in Latin America(developing only) to that in Low & middle income?
Provide a succinct answer. 0.1. What is the ratio of the Aid flow from UN agencies (US$) of 2011 in Latin America(developing only) to that in Low & middle income?
Your answer should be very brief. 0.09. What is the ratio of the Aid flow from UN agencies (US$) in 2012 in Latin America(developing only) to that in Low & middle income?
Your answer should be compact. 0.09. What is the ratio of the Aid flow from UN agencies (US$) in 2009 in Latin America(developing only) to that in Middle income?
Your answer should be compact. 2. What is the ratio of the Aid flow from UN agencies (US$) of 2010 in Latin America(developing only) to that in Middle income?
Give a very brief answer. 1.5. What is the ratio of the Aid flow from UN agencies (US$) in 2011 in Latin America(developing only) to that in Middle income?
Your answer should be compact. 0.43. What is the ratio of the Aid flow from UN agencies (US$) of 2012 in Latin America(developing only) to that in Middle income?
Offer a very short reply. 0.45. What is the ratio of the Aid flow from UN agencies (US$) in 2009 in Latin America(developing only) to that in Sub-Saharan Africa (all income levels)?
Provide a short and direct response. 0.4. What is the ratio of the Aid flow from UN agencies (US$) of 2010 in Latin America(developing only) to that in Sub-Saharan Africa (all income levels)?
Provide a succinct answer. 0.42. What is the ratio of the Aid flow from UN agencies (US$) in 2011 in Latin America(developing only) to that in Sub-Saharan Africa (all income levels)?
Ensure brevity in your answer.  0.37. What is the ratio of the Aid flow from UN agencies (US$) of 2012 in Latin America(developing only) to that in Sub-Saharan Africa (all income levels)?
Give a very brief answer. 0.41. What is the ratio of the Aid flow from UN agencies (US$) in 2009 in Latin America(developing only) to that in Sub-Saharan Africa (developing only)?
Provide a succinct answer. 0.4. What is the ratio of the Aid flow from UN agencies (US$) of 2010 in Latin America(developing only) to that in Sub-Saharan Africa (developing only)?
Offer a terse response. 0.42. What is the ratio of the Aid flow from UN agencies (US$) of 2011 in Latin America(developing only) to that in Sub-Saharan Africa (developing only)?
Your response must be concise. 0.37. What is the ratio of the Aid flow from UN agencies (US$) in 2012 in Latin America(developing only) to that in Sub-Saharan Africa (developing only)?
Your answer should be very brief. 0.42. What is the ratio of the Aid flow from UN agencies (US$) of 2009 in Low & middle income to that in Middle income?
Your response must be concise. 21. What is the ratio of the Aid flow from UN agencies (US$) of 2010 in Low & middle income to that in Middle income?
Offer a very short reply. 14.61. What is the ratio of the Aid flow from UN agencies (US$) in 2011 in Low & middle income to that in Middle income?
Make the answer very short. 5.02. What is the ratio of the Aid flow from UN agencies (US$) of 2012 in Low & middle income to that in Middle income?
Make the answer very short. 4.76. What is the ratio of the Aid flow from UN agencies (US$) of 2009 in Low & middle income to that in Sub-Saharan Africa (all income levels)?
Provide a short and direct response. 4.22. What is the ratio of the Aid flow from UN agencies (US$) in 2010 in Low & middle income to that in Sub-Saharan Africa (all income levels)?
Offer a very short reply. 4.08. What is the ratio of the Aid flow from UN agencies (US$) in 2011 in Low & middle income to that in Sub-Saharan Africa (all income levels)?
Your answer should be compact. 4.25. What is the ratio of the Aid flow from UN agencies (US$) of 2012 in Low & middle income to that in Sub-Saharan Africa (all income levels)?
Provide a short and direct response. 4.38. What is the ratio of the Aid flow from UN agencies (US$) of 2009 in Low & middle income to that in Sub-Saharan Africa (developing only)?
Keep it short and to the point. 4.22. What is the ratio of the Aid flow from UN agencies (US$) in 2010 in Low & middle income to that in Sub-Saharan Africa (developing only)?
Provide a short and direct response. 4.08. What is the ratio of the Aid flow from UN agencies (US$) of 2011 in Low & middle income to that in Sub-Saharan Africa (developing only)?
Your answer should be very brief. 4.28. What is the ratio of the Aid flow from UN agencies (US$) in 2012 in Low & middle income to that in Sub-Saharan Africa (developing only)?
Provide a short and direct response. 4.41. What is the ratio of the Aid flow from UN agencies (US$) in 2009 in Middle income to that in Sub-Saharan Africa (all income levels)?
Ensure brevity in your answer.  0.2. What is the ratio of the Aid flow from UN agencies (US$) of 2010 in Middle income to that in Sub-Saharan Africa (all income levels)?
Your answer should be compact. 0.28. What is the ratio of the Aid flow from UN agencies (US$) of 2011 in Middle income to that in Sub-Saharan Africa (all income levels)?
Your answer should be compact. 0.85. What is the ratio of the Aid flow from UN agencies (US$) in 2012 in Middle income to that in Sub-Saharan Africa (all income levels)?
Your answer should be very brief. 0.92. What is the ratio of the Aid flow from UN agencies (US$) in 2009 in Middle income to that in Sub-Saharan Africa (developing only)?
Ensure brevity in your answer.  0.2. What is the ratio of the Aid flow from UN agencies (US$) of 2010 in Middle income to that in Sub-Saharan Africa (developing only)?
Ensure brevity in your answer.  0.28. What is the ratio of the Aid flow from UN agencies (US$) of 2011 in Middle income to that in Sub-Saharan Africa (developing only)?
Keep it short and to the point. 0.85. What is the ratio of the Aid flow from UN agencies (US$) of 2012 in Middle income to that in Sub-Saharan Africa (developing only)?
Your answer should be compact. 0.93. What is the ratio of the Aid flow from UN agencies (US$) of 2009 in Sub-Saharan Africa (all income levels) to that in Sub-Saharan Africa (developing only)?
Provide a succinct answer. 1. What is the ratio of the Aid flow from UN agencies (US$) in 2011 in Sub-Saharan Africa (all income levels) to that in Sub-Saharan Africa (developing only)?
Provide a short and direct response. 1.01. What is the ratio of the Aid flow from UN agencies (US$) of 2012 in Sub-Saharan Africa (all income levels) to that in Sub-Saharan Africa (developing only)?
Provide a short and direct response. 1.01. What is the difference between the highest and the second highest Aid flow from UN agencies (US$) of 2009?
Your answer should be very brief. 3.33e+08. What is the difference between the highest and the second highest Aid flow from UN agencies (US$) in 2010?
Your response must be concise. 2.76e+08. What is the difference between the highest and the second highest Aid flow from UN agencies (US$) of 2011?
Your answer should be very brief. 3.45e+08. What is the difference between the highest and the second highest Aid flow from UN agencies (US$) in 2012?
Make the answer very short. 3.06e+08. What is the difference between the highest and the lowest Aid flow from UN agencies (US$) of 2009?
Ensure brevity in your answer.  4.16e+08. What is the difference between the highest and the lowest Aid flow from UN agencies (US$) in 2010?
Your response must be concise. 3.41e+08. What is the difference between the highest and the lowest Aid flow from UN agencies (US$) of 2011?
Give a very brief answer. 4.13e+08. What is the difference between the highest and the lowest Aid flow from UN agencies (US$) of 2012?
Provide a short and direct response. 3.59e+08. 